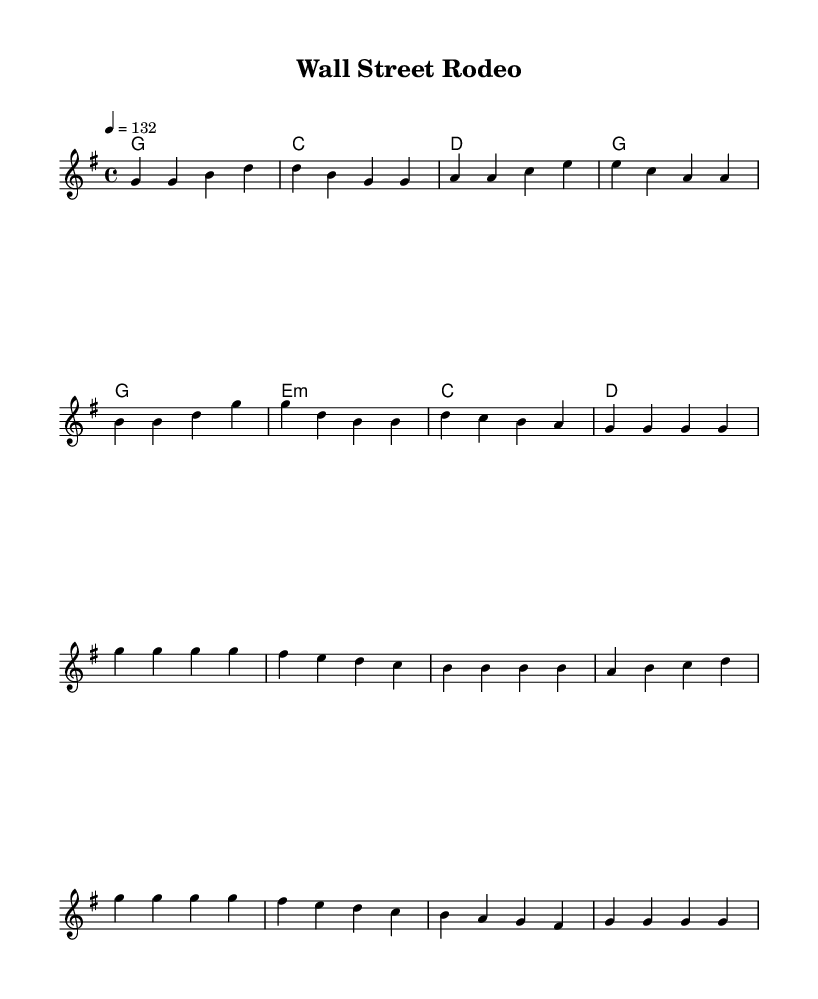What is the key signature of this music? The key signature shows a G major key, indicated by one sharp (F#) visible at the beginning of the staff.
Answer: G major What is the time signature of the piece? The time signature is 4/4, which is displayed at the beginning of the score right after the key signature, denoting four beats per measure.
Answer: 4/4 What is the tempo marking for the song? The tempo marking is 132 beats per minute, specified as "4 = 132" in the global music settings at the beginning of the sheet music.
Answer: 132 How many measures are in the chorus section? The chorus section consists of 8 measures, as counted from the beginning to the end of this specific part in the sheet music.
Answer: 8 What is the first lyric of the verse? The first lyric of the verse is "Crunching," appearing above the first note of the melody in the verse section of the lyrics.
Answer: Crunching Which chord follows the first measure of the verse? The chord following the first measure of the verse is a G major chord, indicated by "g1" under the first measure of melody.
Answer: G major What theme is prevalent in the lyrics of the song? The prevalent theme in the lyrics revolves around financial success and achievements, as depicted through references to Wall Street and portfolios in the lyrics.
Answer: Financial success 